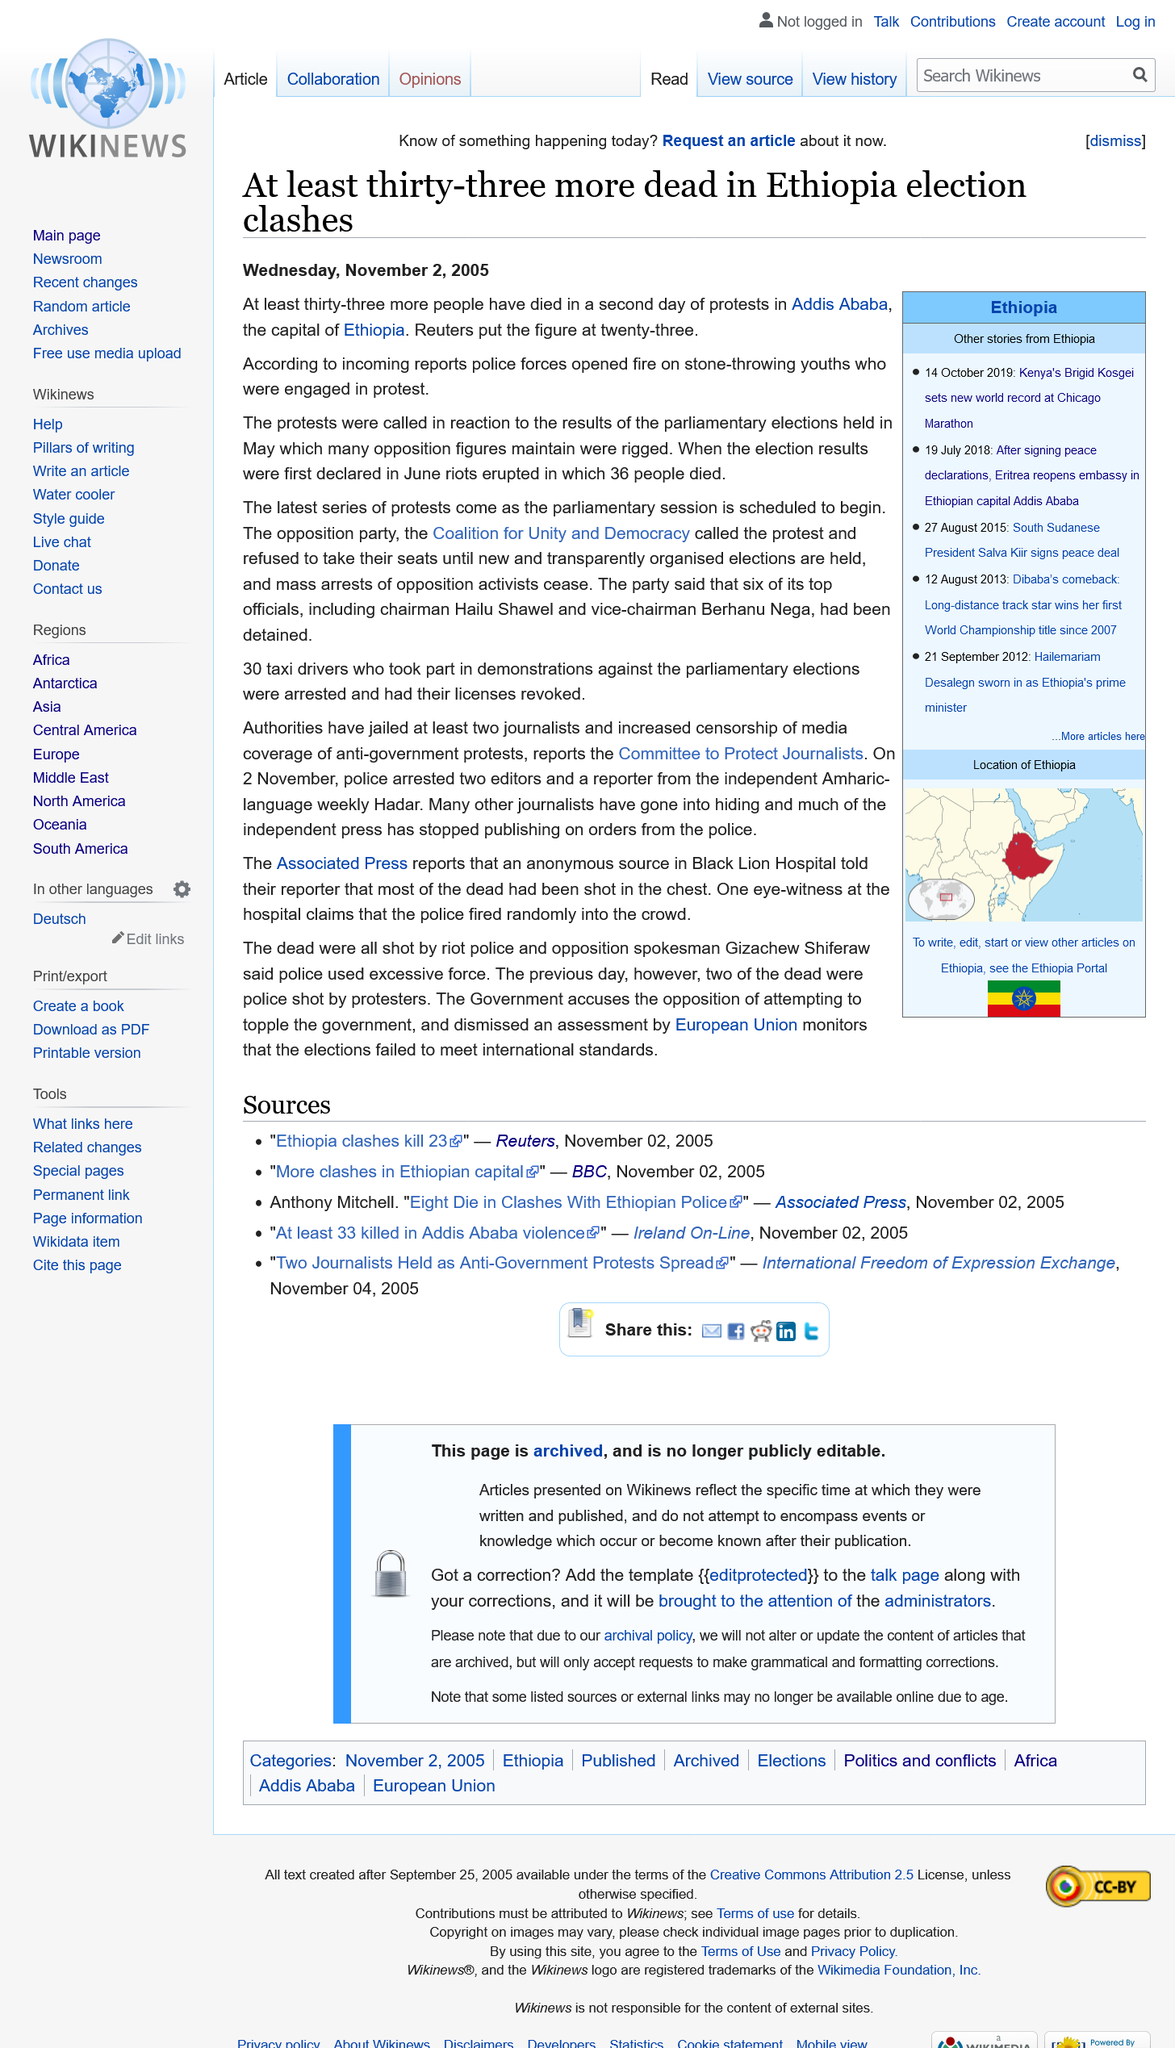Mention a couple of crucial points in this snapshot. On the second day of protests, police reportedly opened fire on unarmed demonstrators, resulting in the tragic deaths of numerous individuals. 36 individuals lost their lives when the election results were first declared in June. In the second day of protests, a total of 33 people lost their lives. 